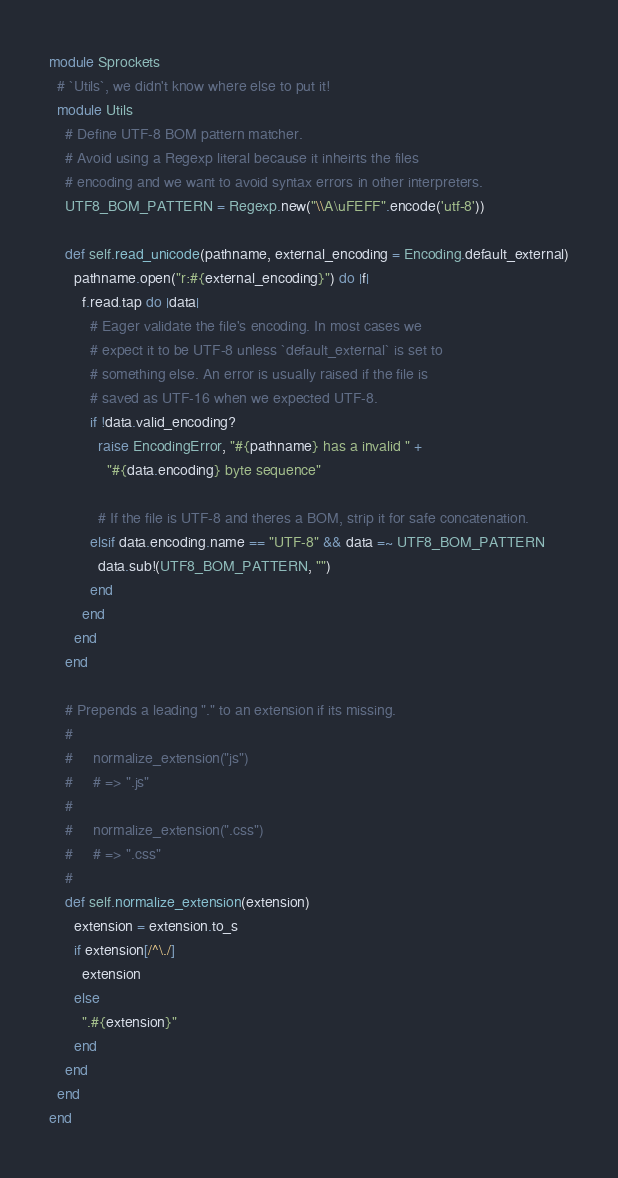<code> <loc_0><loc_0><loc_500><loc_500><_Ruby_>module Sprockets
  # `Utils`, we didn't know where else to put it!
  module Utils
    # Define UTF-8 BOM pattern matcher.
    # Avoid using a Regexp literal because it inheirts the files
    # encoding and we want to avoid syntax errors in other interpreters.
    UTF8_BOM_PATTERN = Regexp.new("\\A\uFEFF".encode('utf-8'))

    def self.read_unicode(pathname, external_encoding = Encoding.default_external)
      pathname.open("r:#{external_encoding}") do |f|
        f.read.tap do |data|
          # Eager validate the file's encoding. In most cases we
          # expect it to be UTF-8 unless `default_external` is set to
          # something else. An error is usually raised if the file is
          # saved as UTF-16 when we expected UTF-8.
          if !data.valid_encoding?
            raise EncodingError, "#{pathname} has a invalid " +
              "#{data.encoding} byte sequence"

            # If the file is UTF-8 and theres a BOM, strip it for safe concatenation.
          elsif data.encoding.name == "UTF-8" && data =~ UTF8_BOM_PATTERN
            data.sub!(UTF8_BOM_PATTERN, "")
          end
        end
      end
    end

    # Prepends a leading "." to an extension if its missing.
    #
    #     normalize_extension("js")
    #     # => ".js"
    #
    #     normalize_extension(".css")
    #     # => ".css"
    #
    def self.normalize_extension(extension)
      extension = extension.to_s
      if extension[/^\./]
        extension
      else
        ".#{extension}"
      end
    end
  end
end
</code> 